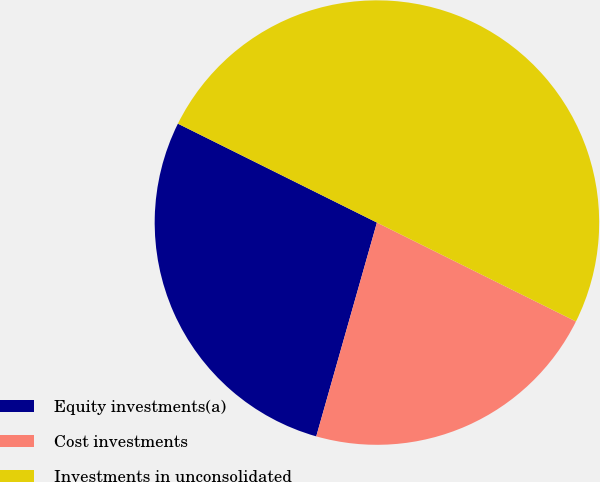Convert chart. <chart><loc_0><loc_0><loc_500><loc_500><pie_chart><fcel>Equity investments(a)<fcel>Cost investments<fcel>Investments in unconsolidated<nl><fcel>27.94%<fcel>22.06%<fcel>50.0%<nl></chart> 